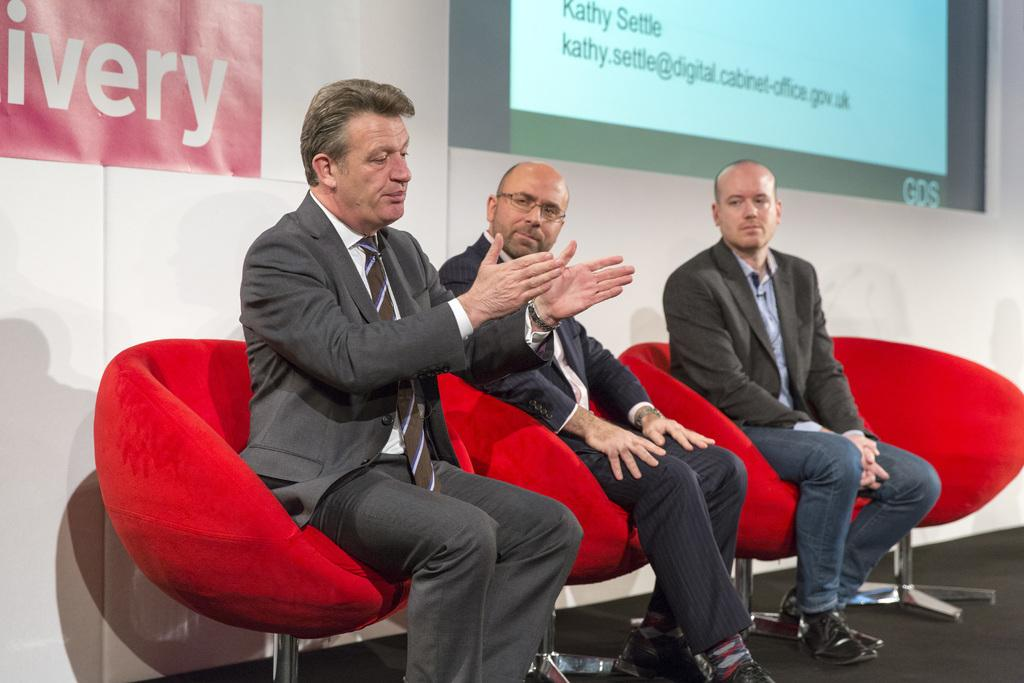What are the men in the image doing? The men in the image are sitting on chairs. What can be seen in the background of the image? There is a screen in the background of the image. What is written or displayed on the board in the image? There is a board with text in the image. Can you tell me how many dogs are present in the image? There are no dogs present in the image. What beliefs do the men in the image share? The provided facts do not give any information about the men's beliefs, so we cannot answer this question. 